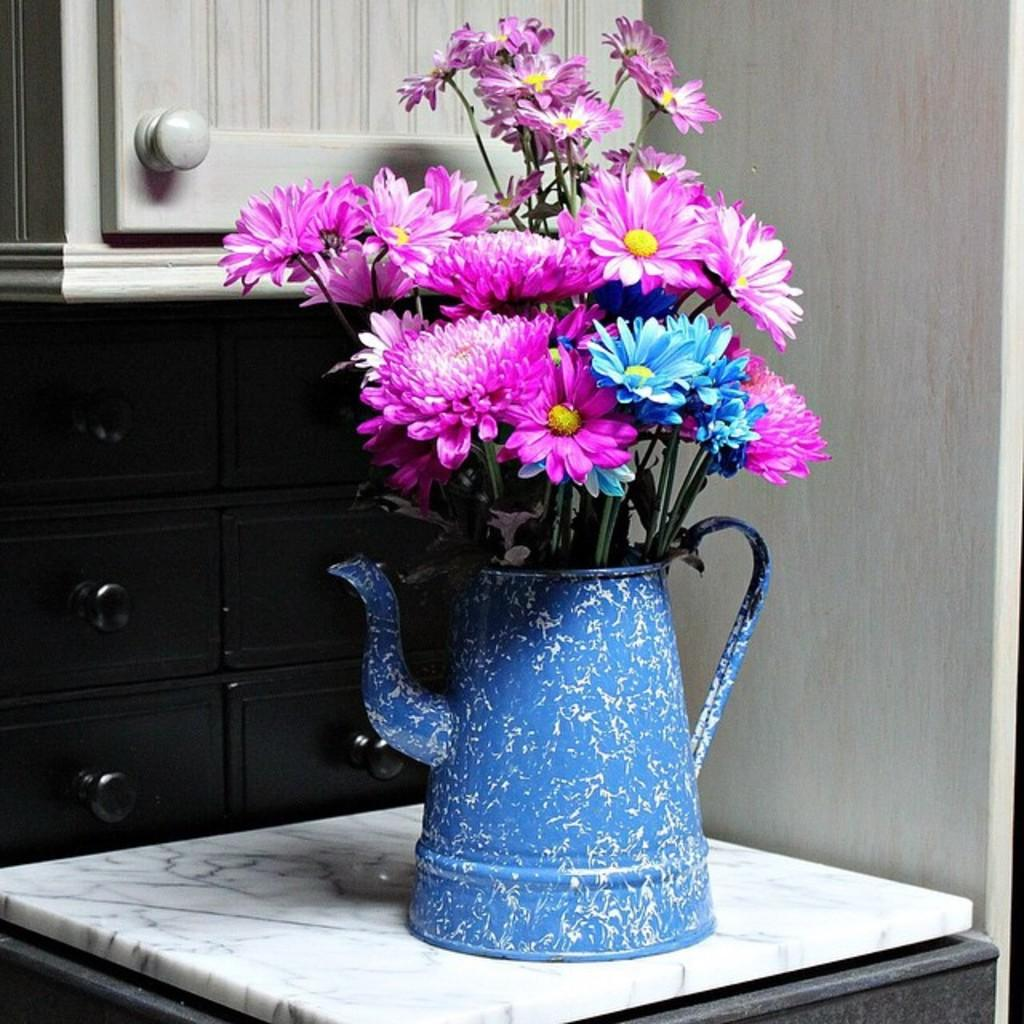What is on the table in the image? There is a teapot on a table in the image. What is inside the teapot? There are flowers in the teapot. What can be seen behind the teapot? There are cupboards behind the teapot. What feature do the cupboards have? The cupboards have knobs. What is to the right of the teapot? There is a wall to the right of the teapot. How many loaves of bread are on the table in the image? There are no loaves of bread present in the image; it features a teapot with flowers inside it. 